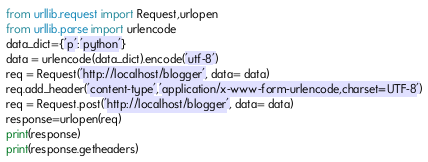<code> <loc_0><loc_0><loc_500><loc_500><_Python_>from urllib.request import Request,urlopen
from urllib.parse import urlencode
data_dict={'p':'python'}
data = urlencode(data_dict).encode('utf-8')
req = Request('http://localhost/blogger', data= data)
req.add_header('content-type','application/x-www-form-urlencode,charset=UTF-8')
req = Request.post('http://localhost/blogger', data= data)
response=urlopen(req)
print(response)
print(response.getheaders)
</code> 